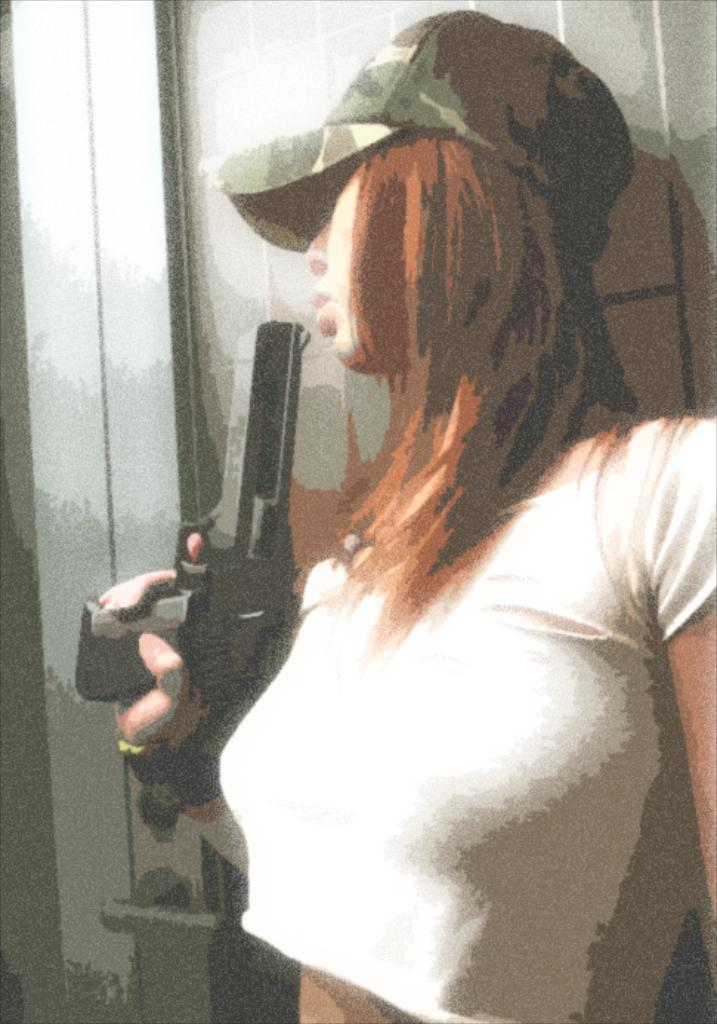Who is present in the image? There is a woman in the image. What is the woman holding in the image? The woman is holding a gun. What type of brush is the woman using to paint the route in the image? There is no brush or painting activity present in the image. The woman is holding a gun, not a brush. 